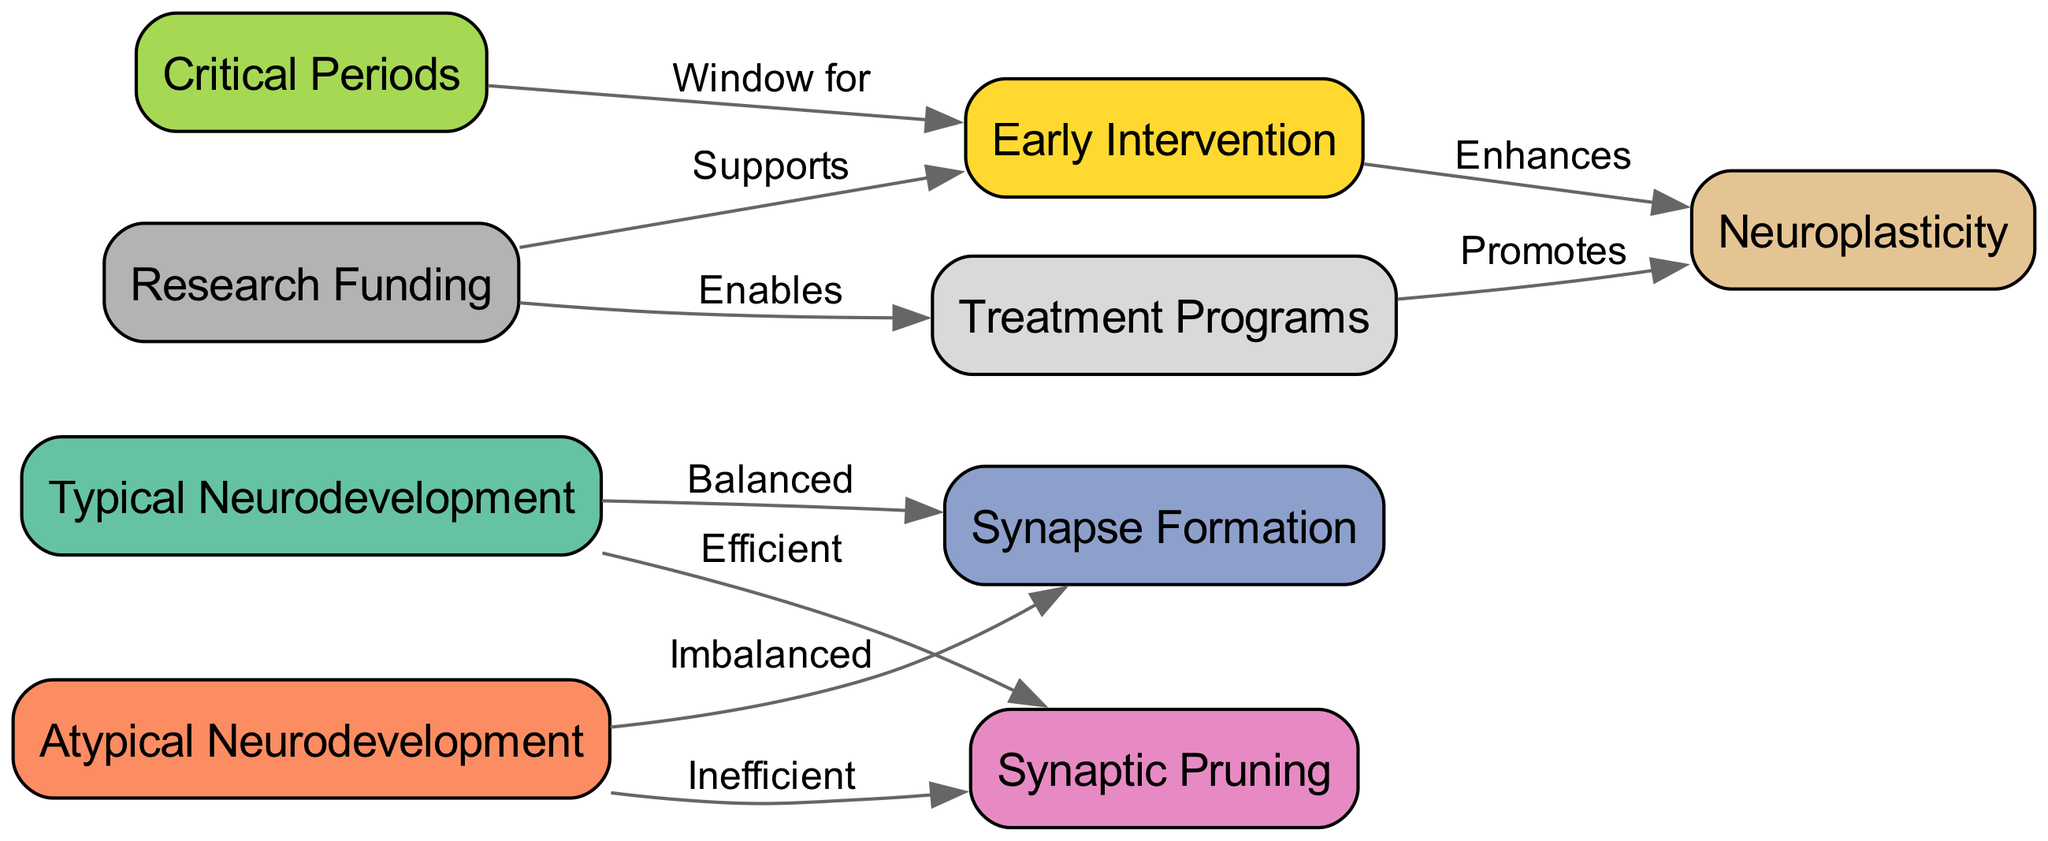What are the two main types of neurodevelopment depicted in the diagram? The diagram shows two types of neurodevelopment: Typical Neurodevelopment and Atypical Neurodevelopment, which are represented as nodes at the beginning of the diagram.
Answer: Typical Neurodevelopment, Atypical Neurodevelopment How does synapse formation differ between typical and atypical neurodevelopment? In the diagram, synapse formation in Typical Neurodevelopment is labeled as "Balanced," while in Atypical Neurodevelopment, it is labeled as "Imbalanced." This shows the contrasting nature of synapse formation in both types.
Answer: Balanced, Imbalanced What is the relationship between critical periods and early intervention? The diagram indicates a "Window for" relationship where Critical Periods leads to Early Intervention, which suggests that there are specific times when interventions are most effective.
Answer: Window for What supports early intervention according to the diagram? Research funding is shown to support early intervention in the diagram, linking the two nodes with an edge labeled "Supports."
Answer: Research Funding Which node promotes neuroplasticity through treatment programs? The diagram illustrates that Treatment Programs promotes Neuroplasticity, as indicated by the edge labeled "Promotes" leading from Treatment Programs to Neuroplasticity.
Answer: Treatment Programs What condition can enhance neuroplasticity in the diagram? The diagram depicts a relationship where Early Intervention enhances Neuroplasticity, demonstrating that interventions can positively impact neuroplasticity.
Answer: Early Intervention How many edges are there connecting to atypical neurodevelopment? The diagram has two edges connected to Atypical Neurodevelopment, one to Synapse Formation and the other to Synaptic Pruning, indicating its relationships.
Answer: 2 What is the color associated with synaptic pruning in the diagram? The diagram uses the color #e78ac3 for the node Synaptic Pruning, making it visually identifiable in the context of the diagram.
Answer: #e78ac3 What outcome does research funding enable according to the diagram? The diagram shows that Research Funding enables Treatment Programs, indicating a flow of support for treatment initiatives.
Answer: Treatment Programs 